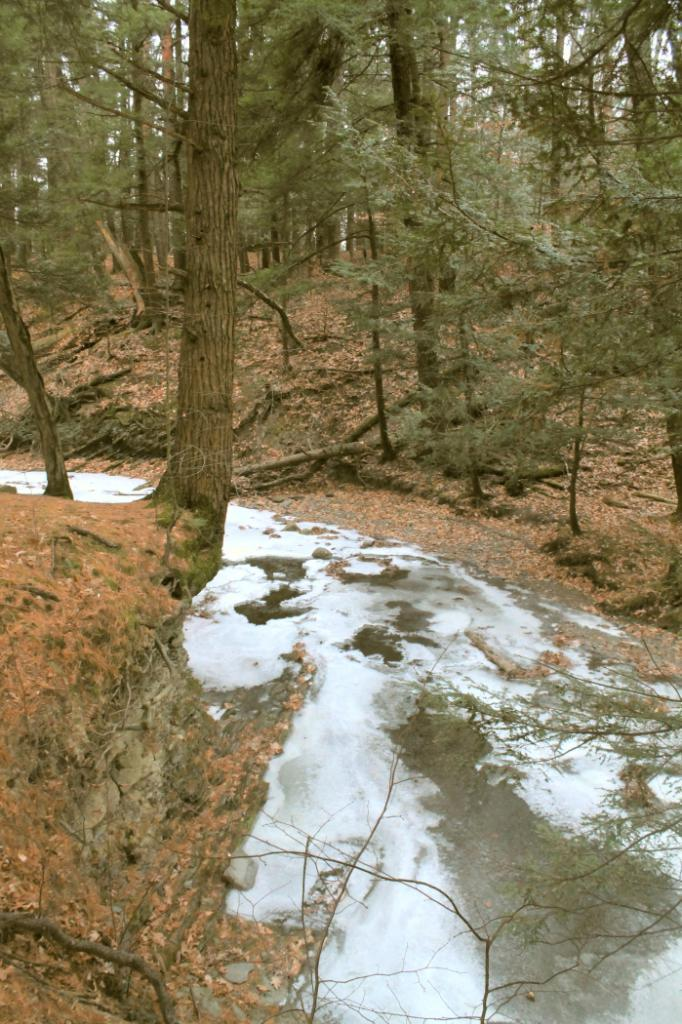What is covering the ground in the image? There is water on the ground in the image. What can be seen in the distance in the image? There are trees visible in the background of the image. Can you see your aunt in the image? There is no mention of an aunt in the image, so it cannot be determined if she is present. 